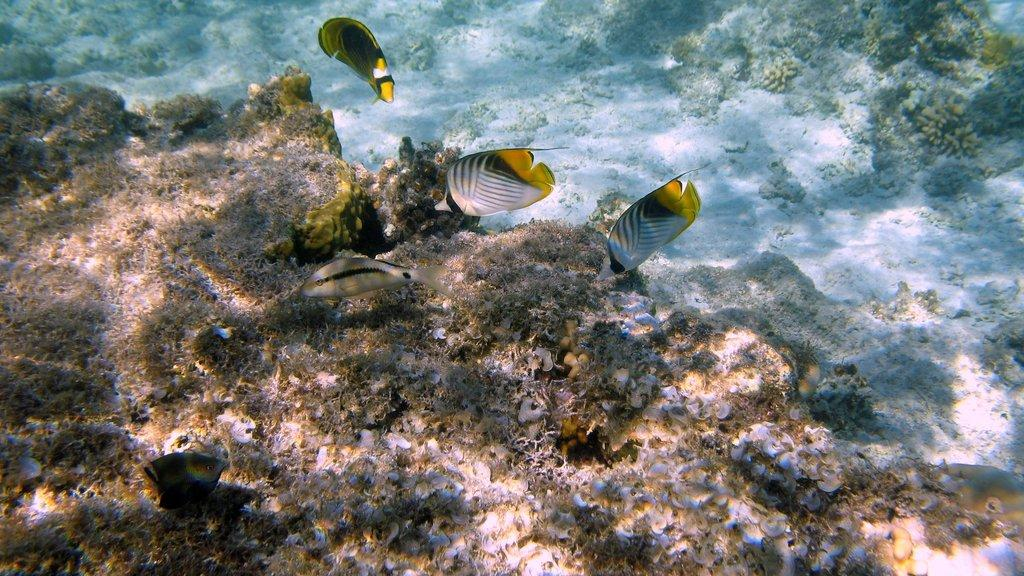What type of environment is depicted in the image? The image is an underwater environment. What types of creatures can be seen in the image? There are aquatic animals in the image. What else can be seen in the underwater environment? There are plants in the image. What is the purpose of the room in the image? There is no room present in the image, as it is an underwater environment. How many frogs can be seen in the image? There are no frogs present in the image, as it features aquatic animals. 